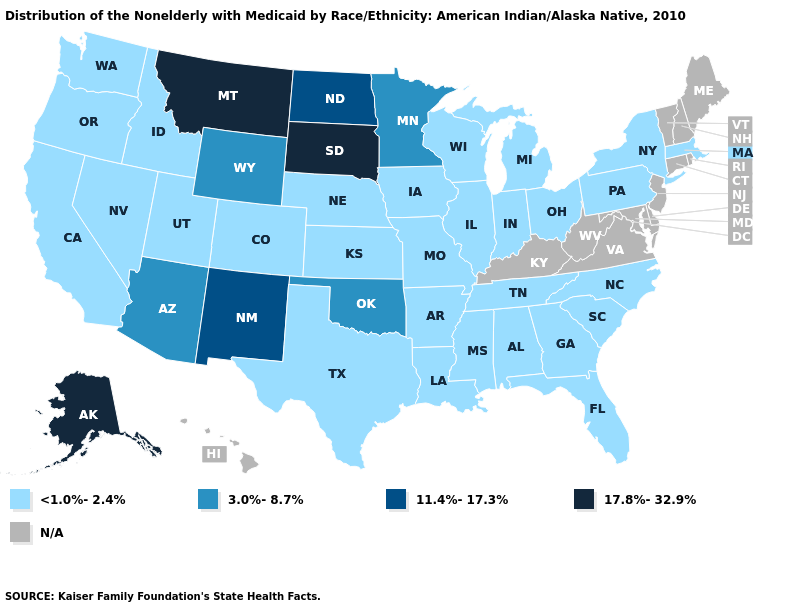Name the states that have a value in the range N/A?
Be succinct. Connecticut, Delaware, Hawaii, Kentucky, Maine, Maryland, New Hampshire, New Jersey, Rhode Island, Vermont, Virginia, West Virginia. What is the lowest value in the Northeast?
Quick response, please. <1.0%-2.4%. Name the states that have a value in the range N/A?
Answer briefly. Connecticut, Delaware, Hawaii, Kentucky, Maine, Maryland, New Hampshire, New Jersey, Rhode Island, Vermont, Virginia, West Virginia. Name the states that have a value in the range N/A?
Be succinct. Connecticut, Delaware, Hawaii, Kentucky, Maine, Maryland, New Hampshire, New Jersey, Rhode Island, Vermont, Virginia, West Virginia. What is the value of Rhode Island?
Short answer required. N/A. Does South Dakota have the highest value in the USA?
Concise answer only. Yes. What is the value of Ohio?
Short answer required. <1.0%-2.4%. What is the value of Oregon?
Give a very brief answer. <1.0%-2.4%. Does Minnesota have the lowest value in the USA?
Short answer required. No. Name the states that have a value in the range 3.0%-8.7%?
Short answer required. Arizona, Minnesota, Oklahoma, Wyoming. Does Missouri have the lowest value in the USA?
Short answer required. Yes. What is the highest value in the Northeast ?
Keep it brief. <1.0%-2.4%. 